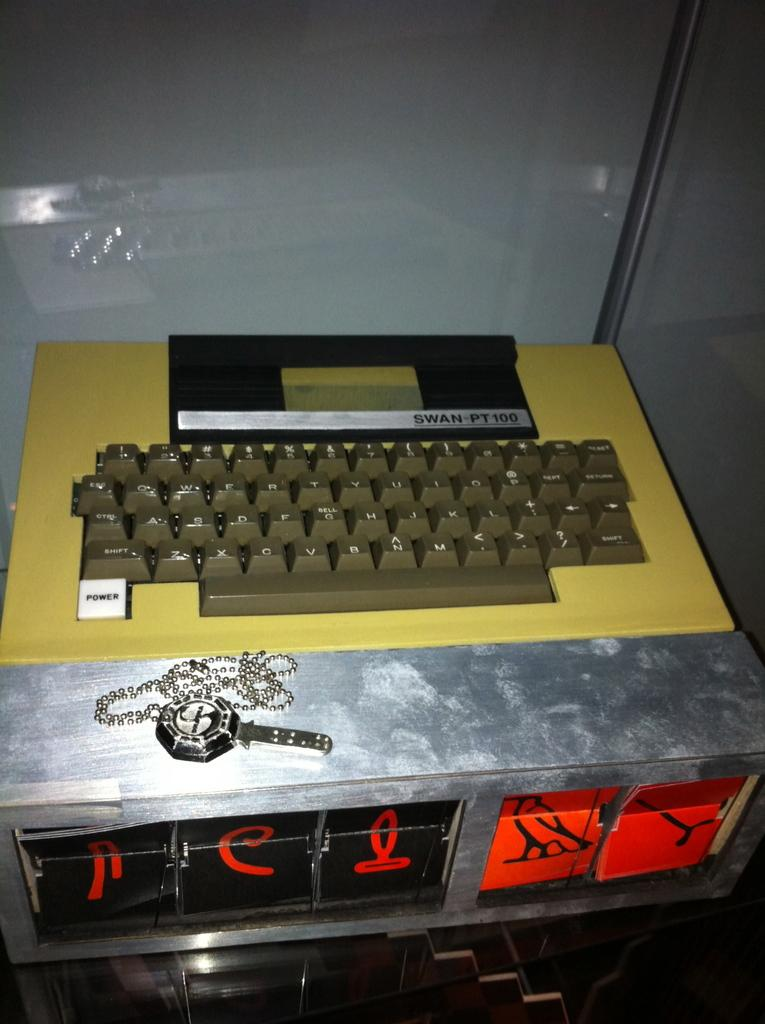<image>
Offer a succinct explanation of the picture presented. A keyboard has a white key that says power 